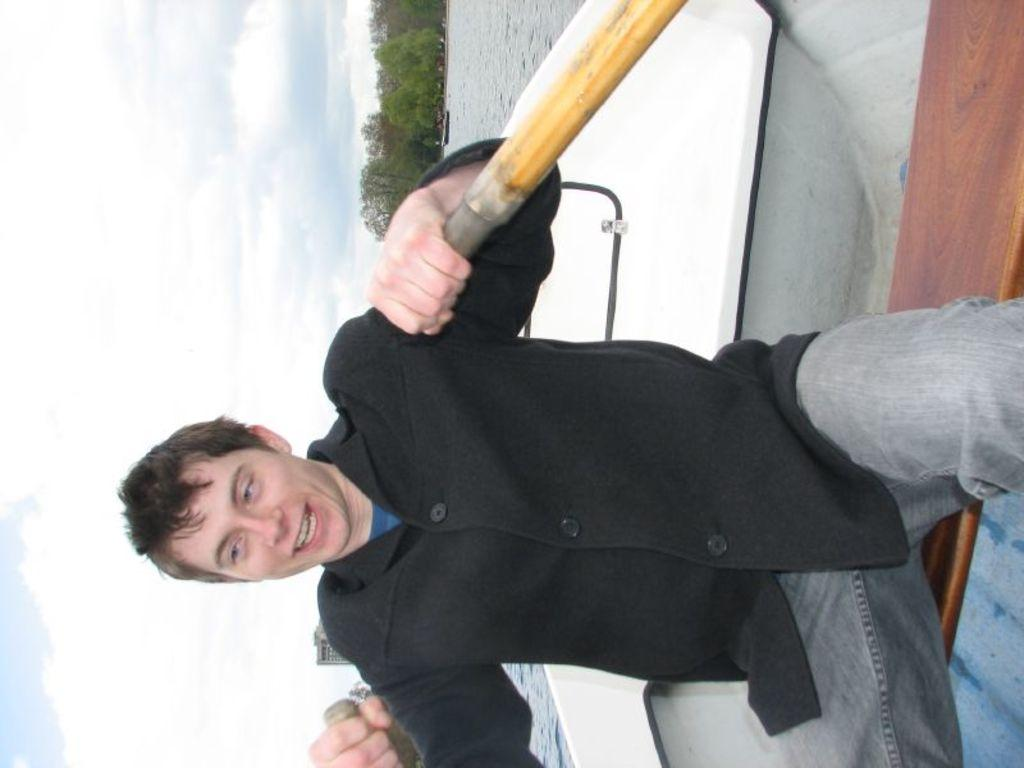What is the person in the image doing? There is a person sailing on a boat in the image. What type of environment can be seen in the image? There are trees and water visible in the image. How would you describe the sky in the background? The sky in the background appears cloudy. What time is displayed on the clock in the image? There is no clock present in the image. How does the person in the image react to the crying baby? There is no baby present in the image, and therefore no crying baby to react to. 